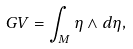Convert formula to latex. <formula><loc_0><loc_0><loc_500><loc_500>G V = \int _ { M } \eta \wedge d \eta ,</formula> 